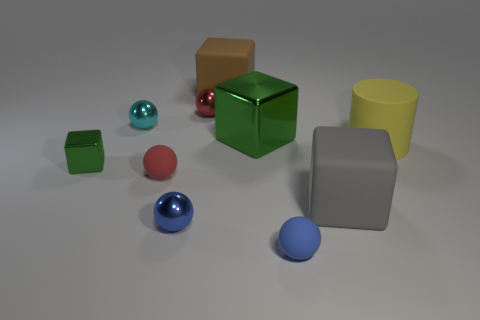Subtract all large blocks. How many blocks are left? 1 Subtract all green blocks. How many blocks are left? 2 Subtract 2 cubes. How many cubes are left? 2 Subtract all cylinders. How many objects are left? 9 Subtract all brown cylinders. How many red balls are left? 2 Add 9 large yellow cylinders. How many large yellow cylinders are left? 10 Add 8 yellow matte cubes. How many yellow matte cubes exist? 8 Subtract 0 purple cylinders. How many objects are left? 10 Subtract all brown cylinders. Subtract all cyan spheres. How many cylinders are left? 1 Subtract all large blue shiny cylinders. Subtract all tiny cyan metallic things. How many objects are left? 9 